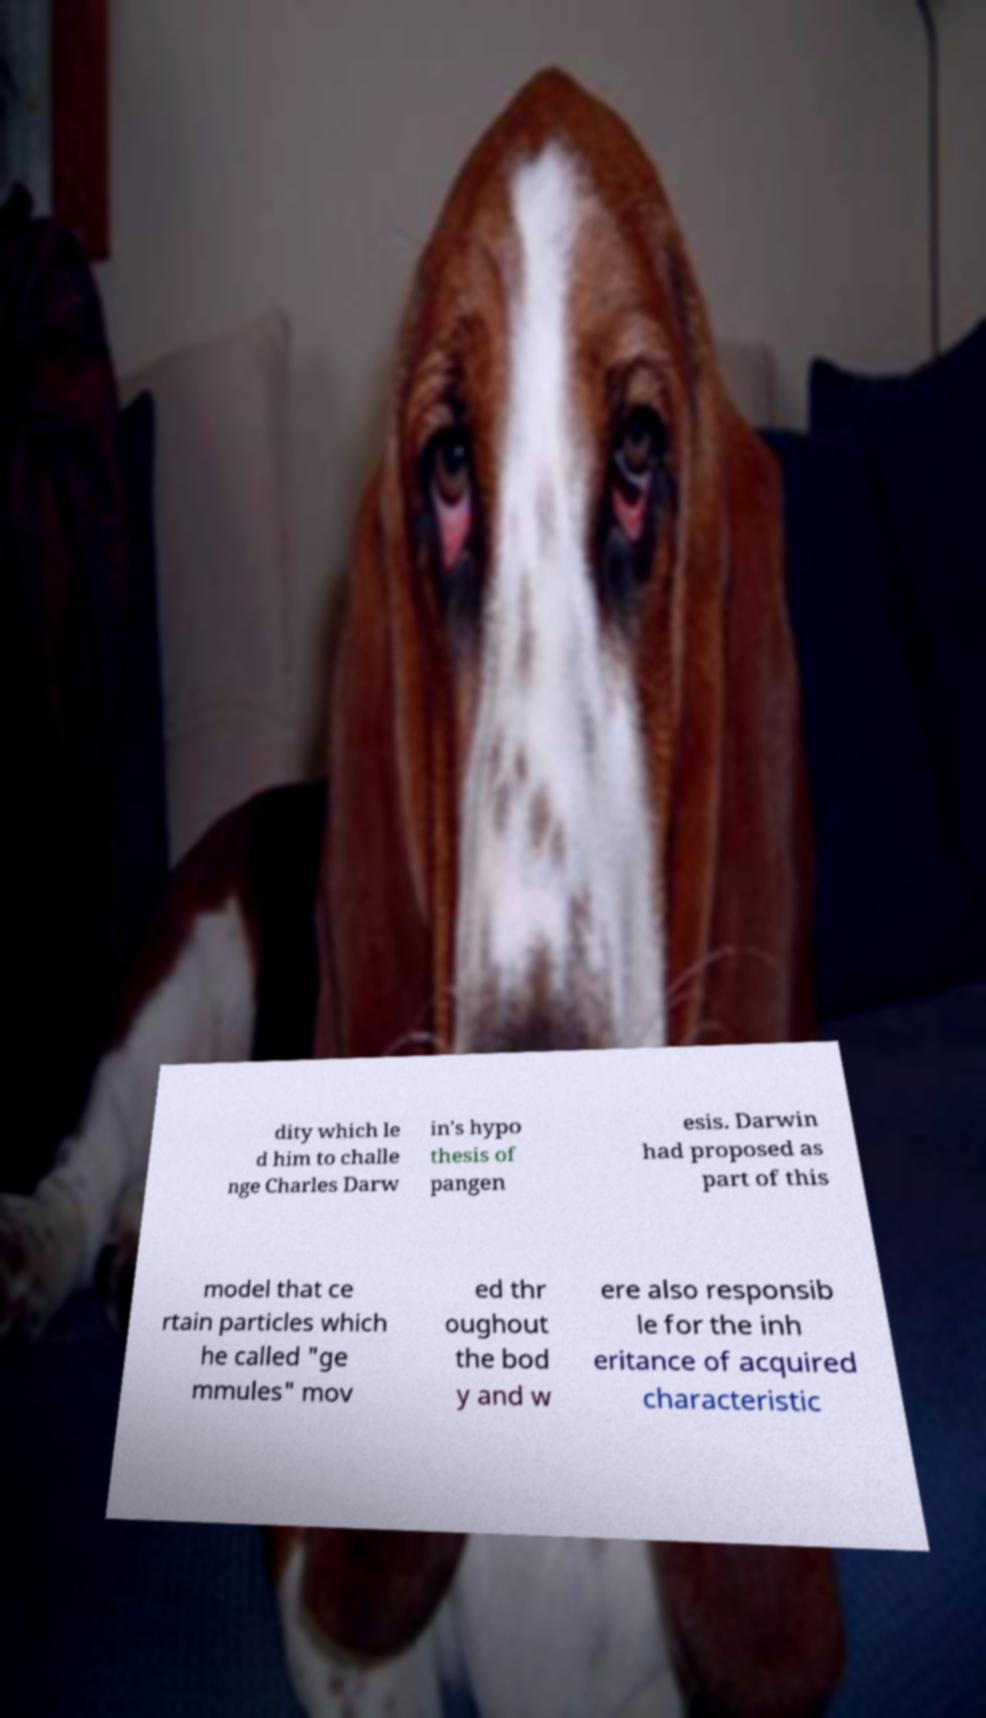Can you accurately transcribe the text from the provided image for me? dity which le d him to challe nge Charles Darw in's hypo thesis of pangen esis. Darwin had proposed as part of this model that ce rtain particles which he called "ge mmules" mov ed thr oughout the bod y and w ere also responsib le for the inh eritance of acquired characteristic 